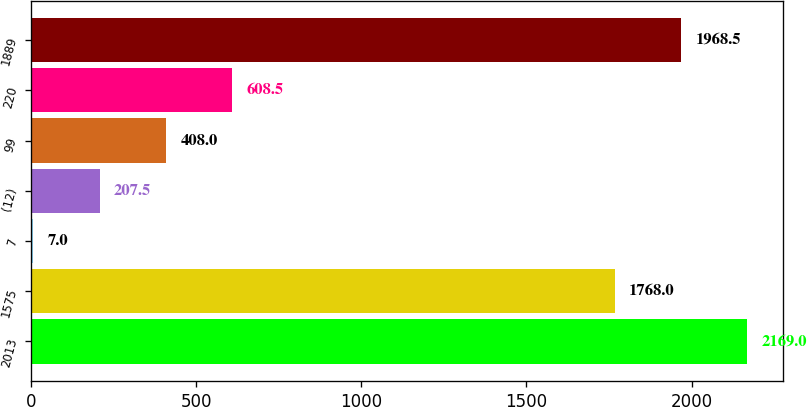Convert chart to OTSL. <chart><loc_0><loc_0><loc_500><loc_500><bar_chart><fcel>2013<fcel>1575<fcel>7<fcel>(12)<fcel>99<fcel>220<fcel>1889<nl><fcel>2169<fcel>1768<fcel>7<fcel>207.5<fcel>408<fcel>608.5<fcel>1968.5<nl></chart> 